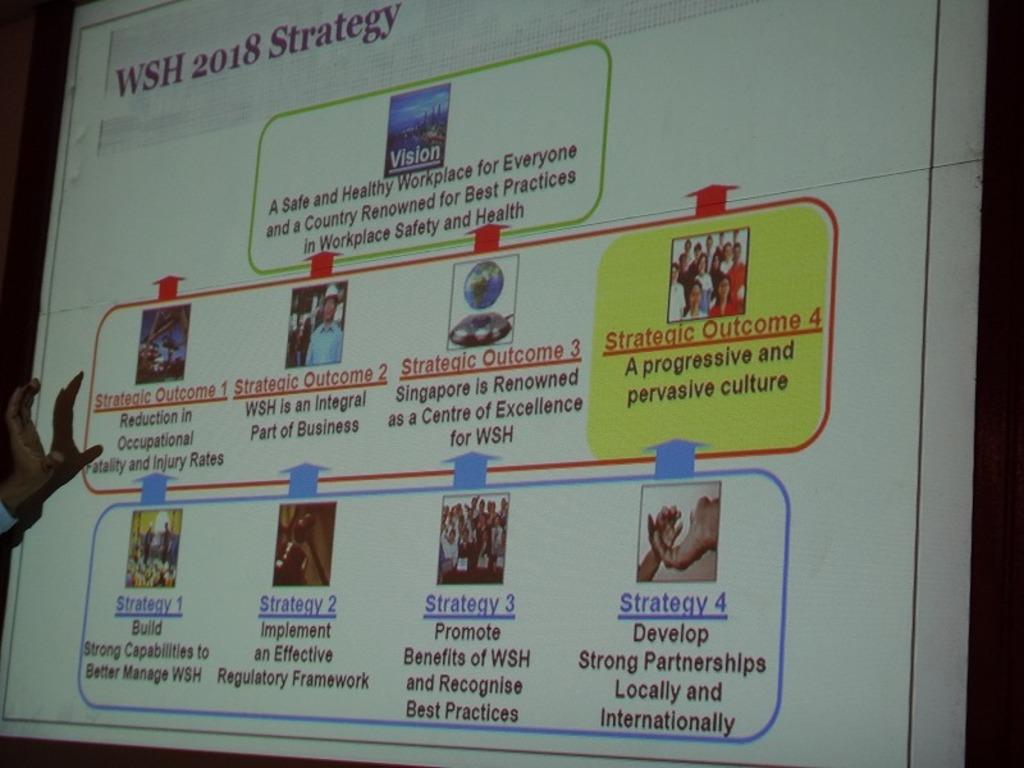What year is displayed?
Keep it short and to the point. 2018. What is the year displayed?
Provide a succinct answer. 2018. 